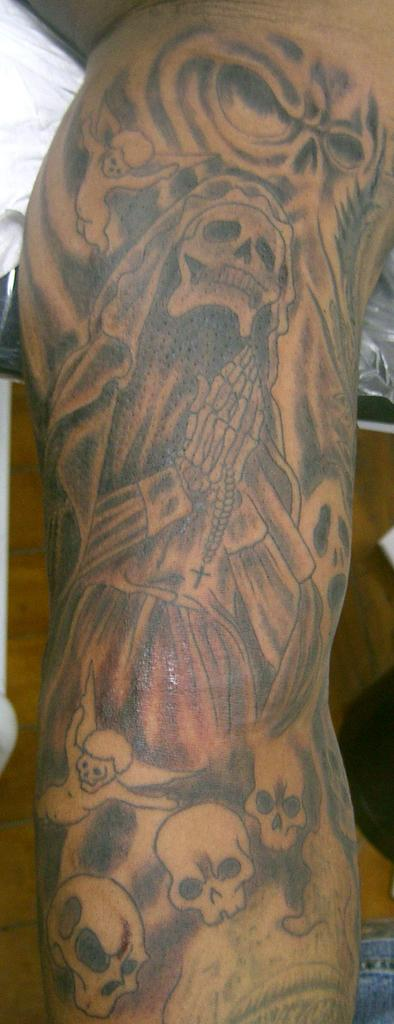What is depicted on the human body in the image? There is a tattoo on a human body in the image. What else can be seen in the image besides the tattoo? There is a white cloth visible in the image. What type of animal is present on the side of the tattoo in the image? There is no animal present in the image; it only features a tattoo on a human body and a white cloth. 